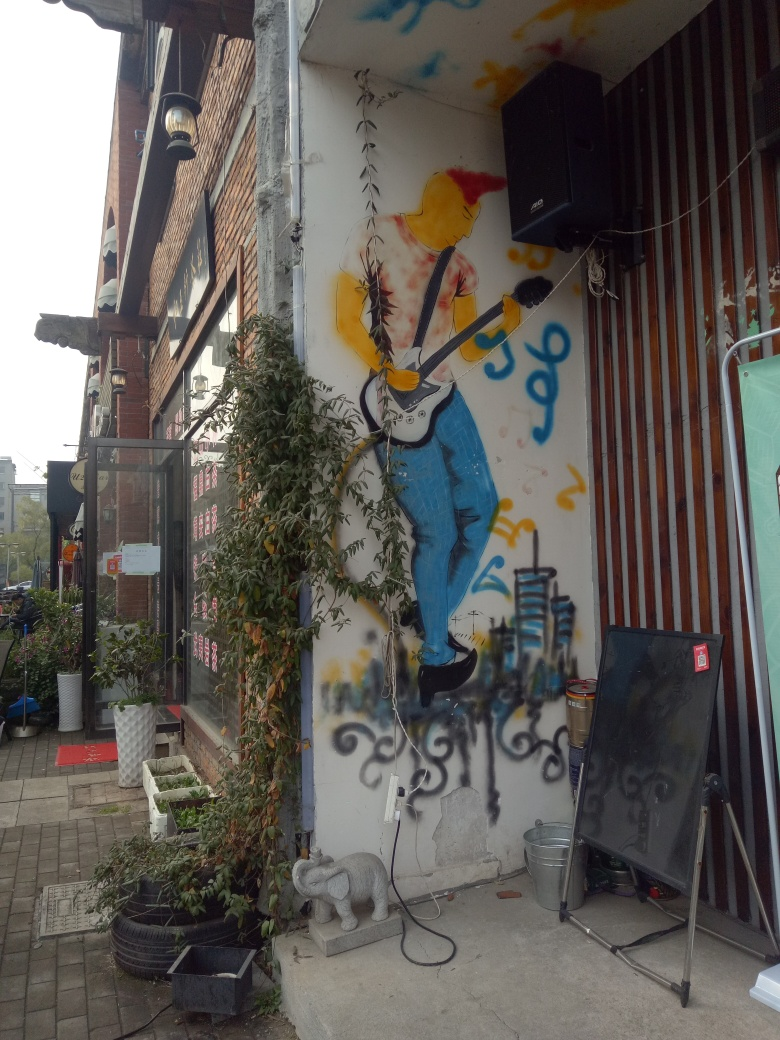Are there any quality issues with this image? Yes, the image has a few quality issues, including slightly blurred areas that may indicate motion blur or a lower resolution capture. Additionally, there's visible noise/artifacts which suggest it might have been taken in low light or with a high ISO setting. The framing could also be improved for better composition. 